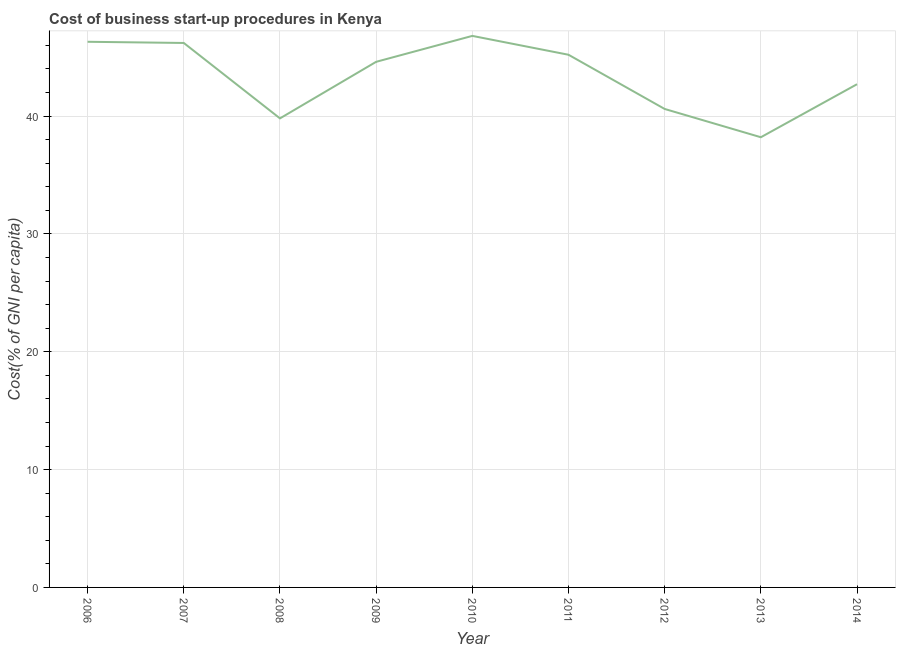What is the cost of business startup procedures in 2009?
Give a very brief answer. 44.6. Across all years, what is the maximum cost of business startup procedures?
Offer a terse response. 46.8. Across all years, what is the minimum cost of business startup procedures?
Offer a very short reply. 38.2. In which year was the cost of business startup procedures minimum?
Make the answer very short. 2013. What is the sum of the cost of business startup procedures?
Your answer should be compact. 390.4. What is the difference between the cost of business startup procedures in 2009 and 2014?
Your answer should be compact. 1.9. What is the average cost of business startup procedures per year?
Make the answer very short. 43.38. What is the median cost of business startup procedures?
Your answer should be very brief. 44.6. Do a majority of the years between 2009 and 2006 (inclusive) have cost of business startup procedures greater than 16 %?
Make the answer very short. Yes. What is the ratio of the cost of business startup procedures in 2010 to that in 2014?
Offer a very short reply. 1.1. Is the difference between the cost of business startup procedures in 2006 and 2010 greater than the difference between any two years?
Give a very brief answer. No. What is the difference between the highest and the second highest cost of business startup procedures?
Keep it short and to the point. 0.5. What is the difference between the highest and the lowest cost of business startup procedures?
Give a very brief answer. 8.6. How many lines are there?
Offer a very short reply. 1. How many years are there in the graph?
Provide a short and direct response. 9. What is the difference between two consecutive major ticks on the Y-axis?
Your answer should be compact. 10. What is the title of the graph?
Keep it short and to the point. Cost of business start-up procedures in Kenya. What is the label or title of the X-axis?
Ensure brevity in your answer.  Year. What is the label or title of the Y-axis?
Provide a succinct answer. Cost(% of GNI per capita). What is the Cost(% of GNI per capita) of 2006?
Make the answer very short. 46.3. What is the Cost(% of GNI per capita) in 2007?
Give a very brief answer. 46.2. What is the Cost(% of GNI per capita) of 2008?
Your response must be concise. 39.8. What is the Cost(% of GNI per capita) in 2009?
Ensure brevity in your answer.  44.6. What is the Cost(% of GNI per capita) of 2010?
Keep it short and to the point. 46.8. What is the Cost(% of GNI per capita) in 2011?
Your response must be concise. 45.2. What is the Cost(% of GNI per capita) of 2012?
Provide a succinct answer. 40.6. What is the Cost(% of GNI per capita) in 2013?
Your response must be concise. 38.2. What is the Cost(% of GNI per capita) in 2014?
Provide a succinct answer. 42.7. What is the difference between the Cost(% of GNI per capita) in 2006 and 2008?
Provide a short and direct response. 6.5. What is the difference between the Cost(% of GNI per capita) in 2006 and 2011?
Your answer should be very brief. 1.1. What is the difference between the Cost(% of GNI per capita) in 2006 and 2012?
Your response must be concise. 5.7. What is the difference between the Cost(% of GNI per capita) in 2006 and 2013?
Provide a succinct answer. 8.1. What is the difference between the Cost(% of GNI per capita) in 2007 and 2008?
Make the answer very short. 6.4. What is the difference between the Cost(% of GNI per capita) in 2007 and 2010?
Make the answer very short. -0.6. What is the difference between the Cost(% of GNI per capita) in 2007 and 2012?
Ensure brevity in your answer.  5.6. What is the difference between the Cost(% of GNI per capita) in 2007 and 2013?
Give a very brief answer. 8. What is the difference between the Cost(% of GNI per capita) in 2008 and 2010?
Your answer should be compact. -7. What is the difference between the Cost(% of GNI per capita) in 2008 and 2014?
Your answer should be compact. -2.9. What is the difference between the Cost(% of GNI per capita) in 2009 and 2011?
Keep it short and to the point. -0.6. What is the difference between the Cost(% of GNI per capita) in 2009 and 2013?
Your answer should be very brief. 6.4. What is the difference between the Cost(% of GNI per capita) in 2010 and 2011?
Make the answer very short. 1.6. What is the difference between the Cost(% of GNI per capita) in 2010 and 2014?
Provide a short and direct response. 4.1. What is the difference between the Cost(% of GNI per capita) in 2011 and 2012?
Keep it short and to the point. 4.6. What is the difference between the Cost(% of GNI per capita) in 2011 and 2014?
Your response must be concise. 2.5. What is the difference between the Cost(% of GNI per capita) in 2012 and 2013?
Your answer should be very brief. 2.4. What is the difference between the Cost(% of GNI per capita) in 2012 and 2014?
Your answer should be compact. -2.1. What is the difference between the Cost(% of GNI per capita) in 2013 and 2014?
Keep it short and to the point. -4.5. What is the ratio of the Cost(% of GNI per capita) in 2006 to that in 2007?
Provide a short and direct response. 1. What is the ratio of the Cost(% of GNI per capita) in 2006 to that in 2008?
Provide a succinct answer. 1.16. What is the ratio of the Cost(% of GNI per capita) in 2006 to that in 2009?
Your response must be concise. 1.04. What is the ratio of the Cost(% of GNI per capita) in 2006 to that in 2010?
Your response must be concise. 0.99. What is the ratio of the Cost(% of GNI per capita) in 2006 to that in 2012?
Your answer should be very brief. 1.14. What is the ratio of the Cost(% of GNI per capita) in 2006 to that in 2013?
Your response must be concise. 1.21. What is the ratio of the Cost(% of GNI per capita) in 2006 to that in 2014?
Keep it short and to the point. 1.08. What is the ratio of the Cost(% of GNI per capita) in 2007 to that in 2008?
Make the answer very short. 1.16. What is the ratio of the Cost(% of GNI per capita) in 2007 to that in 2009?
Give a very brief answer. 1.04. What is the ratio of the Cost(% of GNI per capita) in 2007 to that in 2010?
Make the answer very short. 0.99. What is the ratio of the Cost(% of GNI per capita) in 2007 to that in 2012?
Offer a very short reply. 1.14. What is the ratio of the Cost(% of GNI per capita) in 2007 to that in 2013?
Give a very brief answer. 1.21. What is the ratio of the Cost(% of GNI per capita) in 2007 to that in 2014?
Offer a terse response. 1.08. What is the ratio of the Cost(% of GNI per capita) in 2008 to that in 2009?
Offer a very short reply. 0.89. What is the ratio of the Cost(% of GNI per capita) in 2008 to that in 2010?
Provide a short and direct response. 0.85. What is the ratio of the Cost(% of GNI per capita) in 2008 to that in 2011?
Give a very brief answer. 0.88. What is the ratio of the Cost(% of GNI per capita) in 2008 to that in 2012?
Your answer should be compact. 0.98. What is the ratio of the Cost(% of GNI per capita) in 2008 to that in 2013?
Provide a succinct answer. 1.04. What is the ratio of the Cost(% of GNI per capita) in 2008 to that in 2014?
Keep it short and to the point. 0.93. What is the ratio of the Cost(% of GNI per capita) in 2009 to that in 2010?
Provide a succinct answer. 0.95. What is the ratio of the Cost(% of GNI per capita) in 2009 to that in 2011?
Your answer should be compact. 0.99. What is the ratio of the Cost(% of GNI per capita) in 2009 to that in 2012?
Offer a terse response. 1.1. What is the ratio of the Cost(% of GNI per capita) in 2009 to that in 2013?
Ensure brevity in your answer.  1.17. What is the ratio of the Cost(% of GNI per capita) in 2009 to that in 2014?
Offer a terse response. 1.04. What is the ratio of the Cost(% of GNI per capita) in 2010 to that in 2011?
Keep it short and to the point. 1.03. What is the ratio of the Cost(% of GNI per capita) in 2010 to that in 2012?
Provide a succinct answer. 1.15. What is the ratio of the Cost(% of GNI per capita) in 2010 to that in 2013?
Give a very brief answer. 1.23. What is the ratio of the Cost(% of GNI per capita) in 2010 to that in 2014?
Ensure brevity in your answer.  1.1. What is the ratio of the Cost(% of GNI per capita) in 2011 to that in 2012?
Your answer should be very brief. 1.11. What is the ratio of the Cost(% of GNI per capita) in 2011 to that in 2013?
Ensure brevity in your answer.  1.18. What is the ratio of the Cost(% of GNI per capita) in 2011 to that in 2014?
Provide a short and direct response. 1.06. What is the ratio of the Cost(% of GNI per capita) in 2012 to that in 2013?
Your response must be concise. 1.06. What is the ratio of the Cost(% of GNI per capita) in 2012 to that in 2014?
Offer a very short reply. 0.95. What is the ratio of the Cost(% of GNI per capita) in 2013 to that in 2014?
Ensure brevity in your answer.  0.9. 